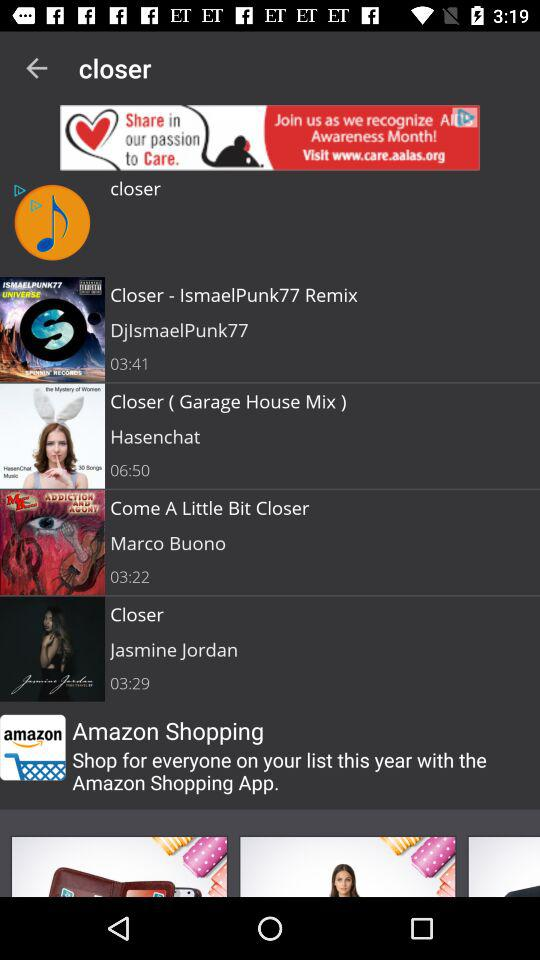What is the song sung by Jasmine Jordan? The song sung by Jasmine Jordan is "Closer". 